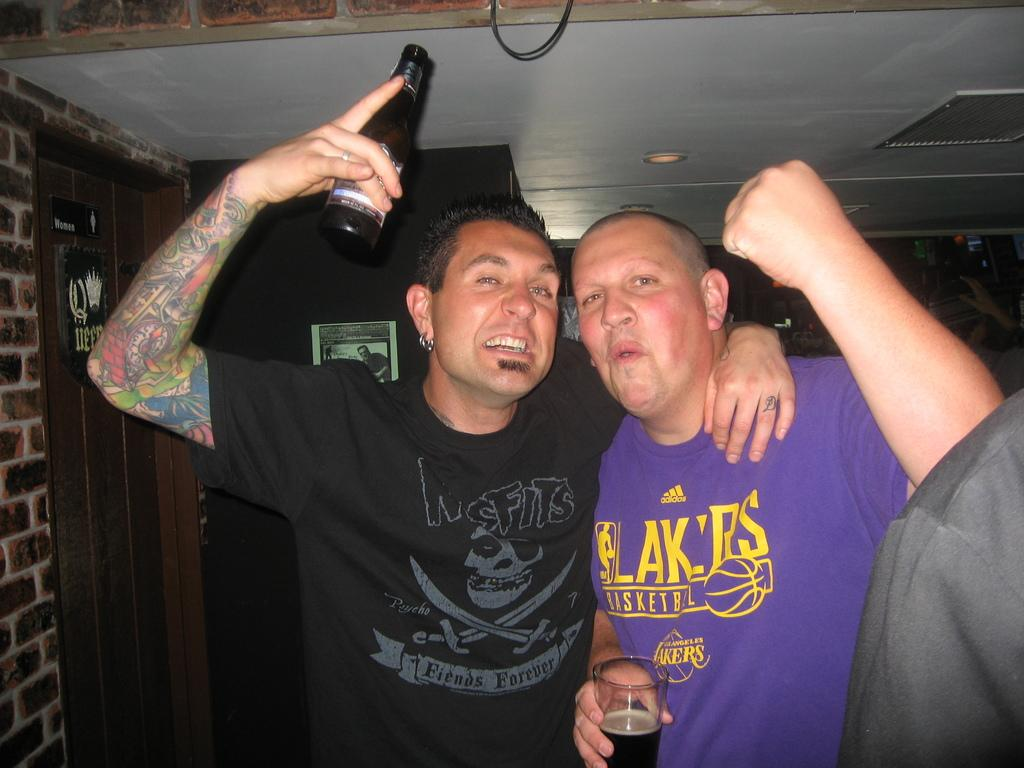What is the main subject of the image? The main subject of the image is a group of people. Can you describe the man on the left side of the image? The man on the left side of the image is holding a beer in his hand. What type of yak can be seen wearing a suit in the image? There is no yak or suit present in the image; it features a group of people, including a man holding a beer. 